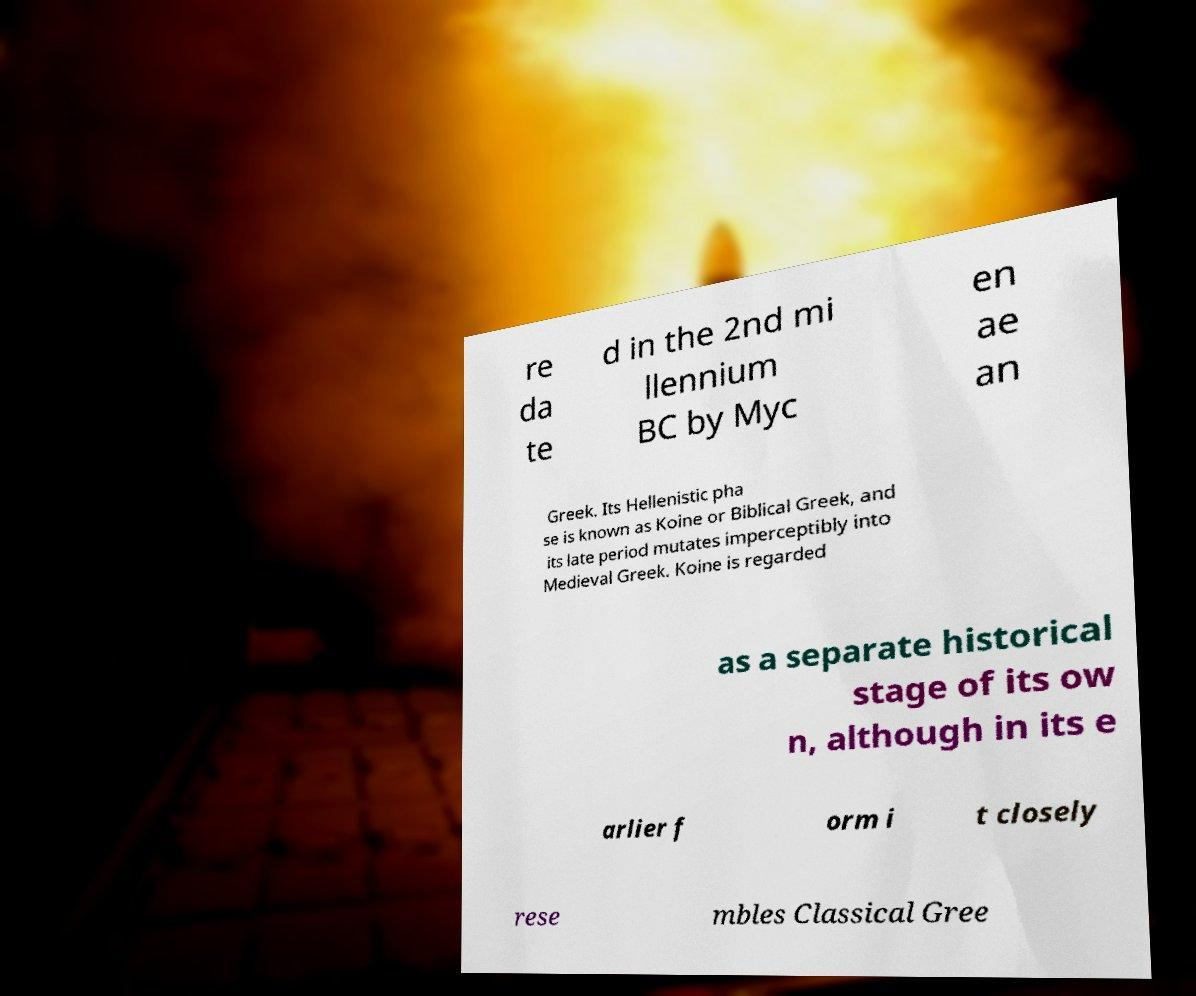There's text embedded in this image that I need extracted. Can you transcribe it verbatim? re da te d in the 2nd mi llennium BC by Myc en ae an Greek. Its Hellenistic pha se is known as Koine or Biblical Greek, and its late period mutates imperceptibly into Medieval Greek. Koine is regarded as a separate historical stage of its ow n, although in its e arlier f orm i t closely rese mbles Classical Gree 